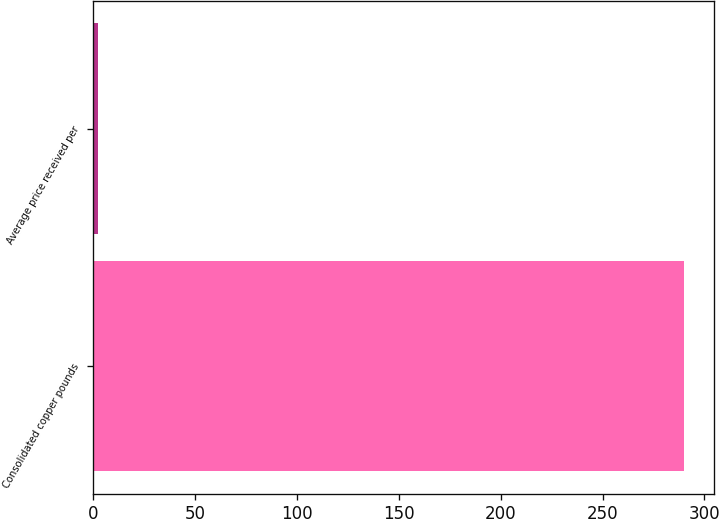<chart> <loc_0><loc_0><loc_500><loc_500><bar_chart><fcel>Consolidated copper pounds<fcel>Average price received per<nl><fcel>290<fcel>2.59<nl></chart> 